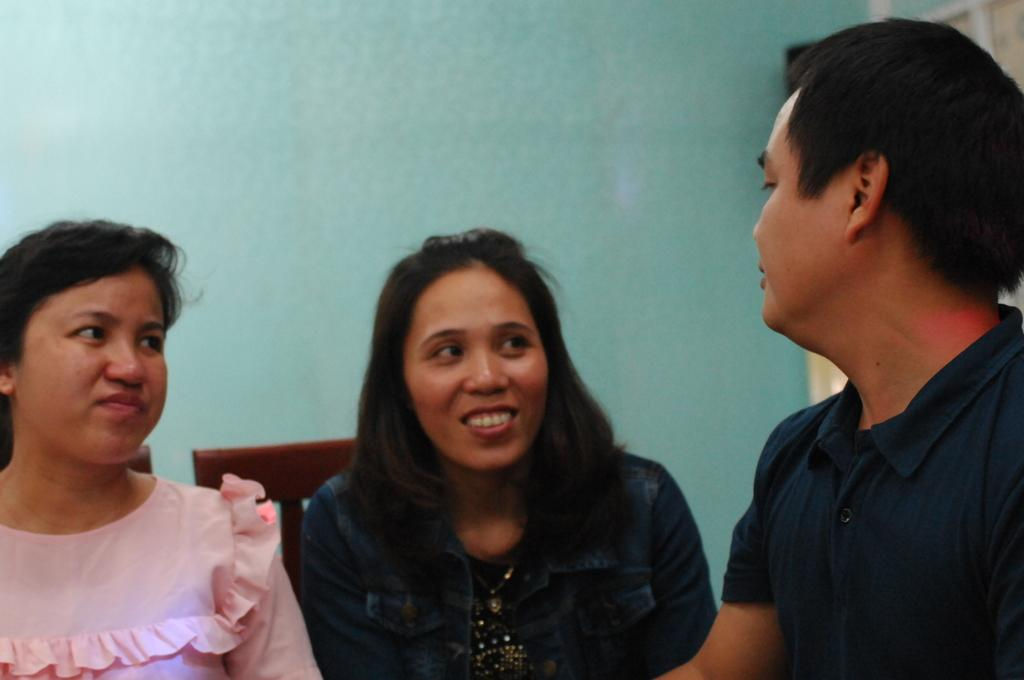How many people are in the image? There are two women and a man in the image, making a total of three individuals. What are the people in the image doing? The individuals are seated on chairs. What can be seen in the background of the image? There is a wall visible in the background of the image. What type of pies are the women holding in the image? A: There are no pies present in the image; the individuals are seated on chairs without any visible objects in their hands. 